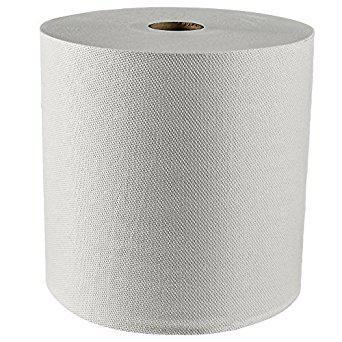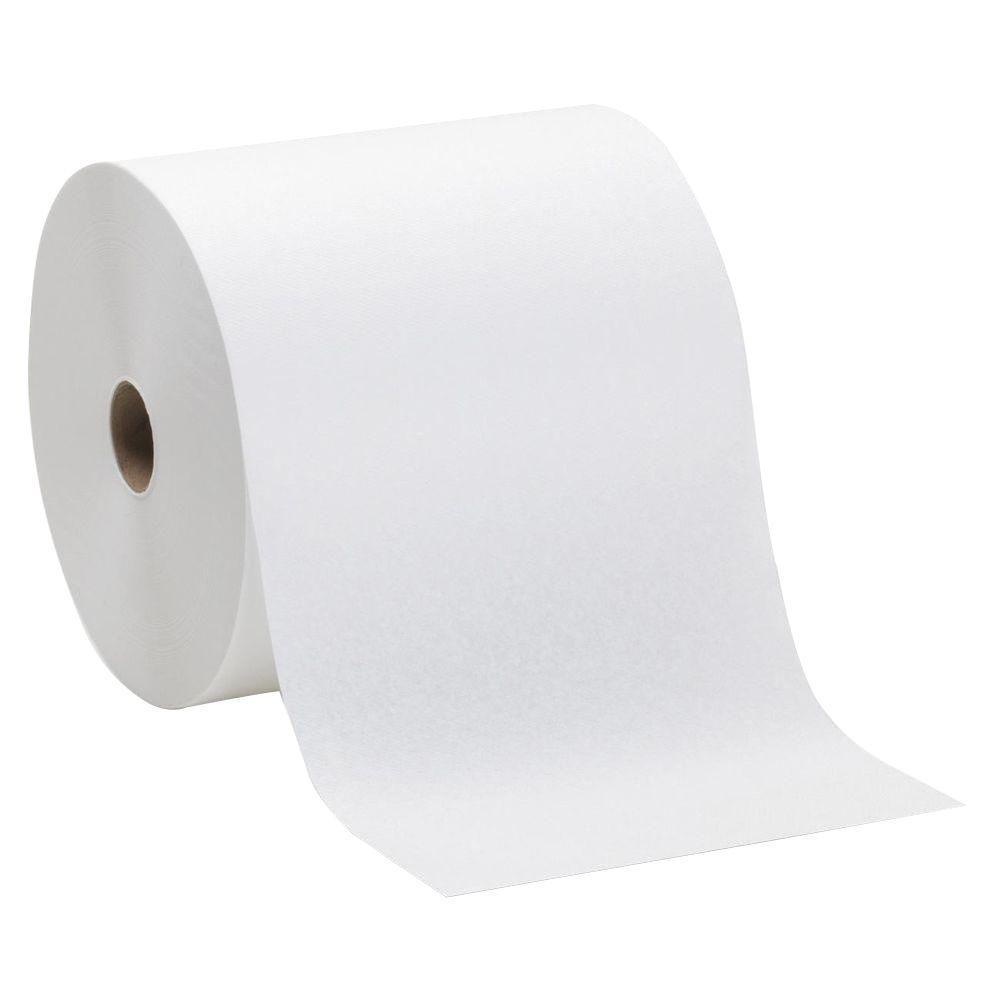The first image is the image on the left, the second image is the image on the right. For the images shown, is this caption "In at least one image there is a single role of toilet paper with and open unruptured hole in the middle with the paper unrolling at least one sheet." true? Answer yes or no. Yes. The first image is the image on the left, the second image is the image on the right. Evaluate the accuracy of this statement regarding the images: "Each image features a single white upright roll of paper towels with no sheet of towel extending out past the roll.". Is it true? Answer yes or no. No. 